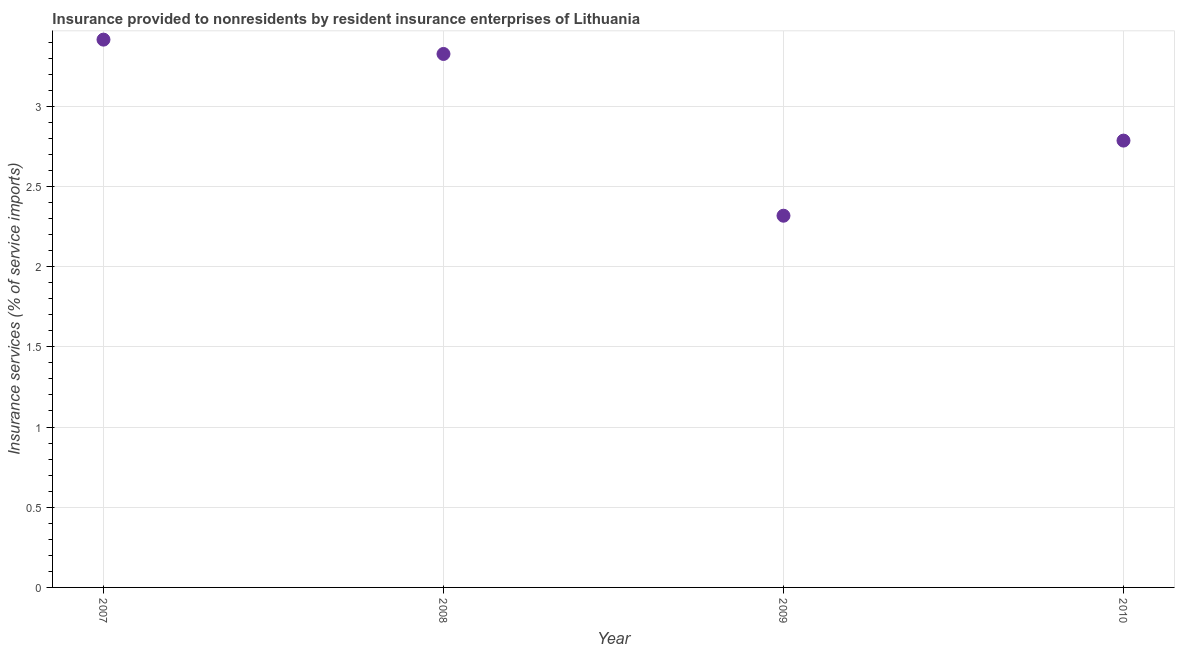What is the insurance and financial services in 2010?
Provide a succinct answer. 2.79. Across all years, what is the maximum insurance and financial services?
Make the answer very short. 3.42. Across all years, what is the minimum insurance and financial services?
Your answer should be very brief. 2.32. In which year was the insurance and financial services minimum?
Make the answer very short. 2009. What is the sum of the insurance and financial services?
Provide a short and direct response. 11.85. What is the difference between the insurance and financial services in 2008 and 2010?
Offer a terse response. 0.54. What is the average insurance and financial services per year?
Offer a terse response. 2.96. What is the median insurance and financial services?
Make the answer very short. 3.06. In how many years, is the insurance and financial services greater than 2.2 %?
Your response must be concise. 4. Do a majority of the years between 2010 and 2008 (inclusive) have insurance and financial services greater than 1.6 %?
Provide a succinct answer. No. What is the ratio of the insurance and financial services in 2008 to that in 2010?
Give a very brief answer. 1.19. What is the difference between the highest and the second highest insurance and financial services?
Make the answer very short. 0.09. What is the difference between the highest and the lowest insurance and financial services?
Your response must be concise. 1.1. How many dotlines are there?
Your response must be concise. 1. How many years are there in the graph?
Give a very brief answer. 4. Does the graph contain any zero values?
Make the answer very short. No. What is the title of the graph?
Offer a terse response. Insurance provided to nonresidents by resident insurance enterprises of Lithuania. What is the label or title of the Y-axis?
Ensure brevity in your answer.  Insurance services (% of service imports). What is the Insurance services (% of service imports) in 2007?
Provide a short and direct response. 3.42. What is the Insurance services (% of service imports) in 2008?
Provide a short and direct response. 3.33. What is the Insurance services (% of service imports) in 2009?
Give a very brief answer. 2.32. What is the Insurance services (% of service imports) in 2010?
Offer a very short reply. 2.79. What is the difference between the Insurance services (% of service imports) in 2007 and 2008?
Offer a very short reply. 0.09. What is the difference between the Insurance services (% of service imports) in 2007 and 2009?
Offer a very short reply. 1.1. What is the difference between the Insurance services (% of service imports) in 2007 and 2010?
Provide a short and direct response. 0.63. What is the difference between the Insurance services (% of service imports) in 2008 and 2009?
Keep it short and to the point. 1.01. What is the difference between the Insurance services (% of service imports) in 2008 and 2010?
Ensure brevity in your answer.  0.54. What is the difference between the Insurance services (% of service imports) in 2009 and 2010?
Offer a terse response. -0.47. What is the ratio of the Insurance services (% of service imports) in 2007 to that in 2009?
Your answer should be compact. 1.47. What is the ratio of the Insurance services (% of service imports) in 2007 to that in 2010?
Your response must be concise. 1.23. What is the ratio of the Insurance services (% of service imports) in 2008 to that in 2009?
Offer a terse response. 1.44. What is the ratio of the Insurance services (% of service imports) in 2008 to that in 2010?
Your response must be concise. 1.19. What is the ratio of the Insurance services (% of service imports) in 2009 to that in 2010?
Your response must be concise. 0.83. 